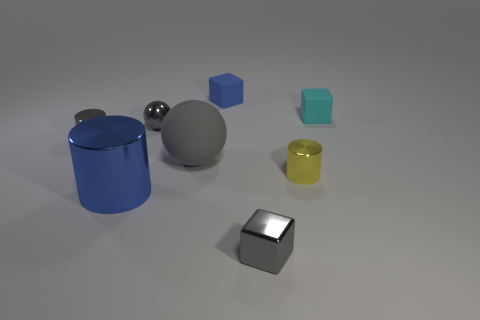Add 1 green matte cylinders. How many objects exist? 9 Subtract all cubes. How many objects are left? 5 Subtract 0 yellow blocks. How many objects are left? 8 Subtract all small red metal things. Subtract all small metallic blocks. How many objects are left? 7 Add 1 gray shiny cylinders. How many gray shiny cylinders are left? 2 Add 6 blue rubber things. How many blue rubber things exist? 7 